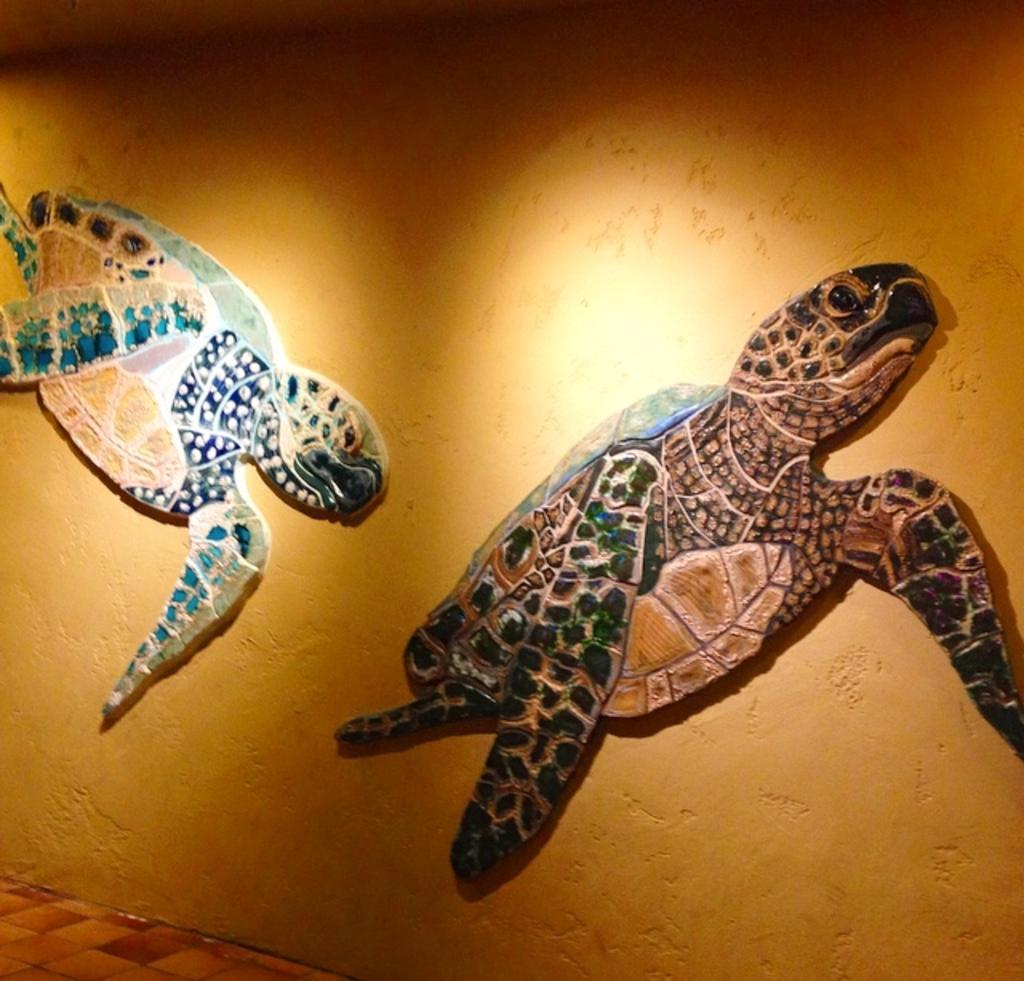What type of animals can be seen on the wall in the image? There are depictions of turtles on the wall in the image. What part of the room can be seen at the bottom of the image? There is a floor visible at the bottom of the image. What type of advertisement can be seen on the floor in the image? There is no advertisement present on the floor in the image. 